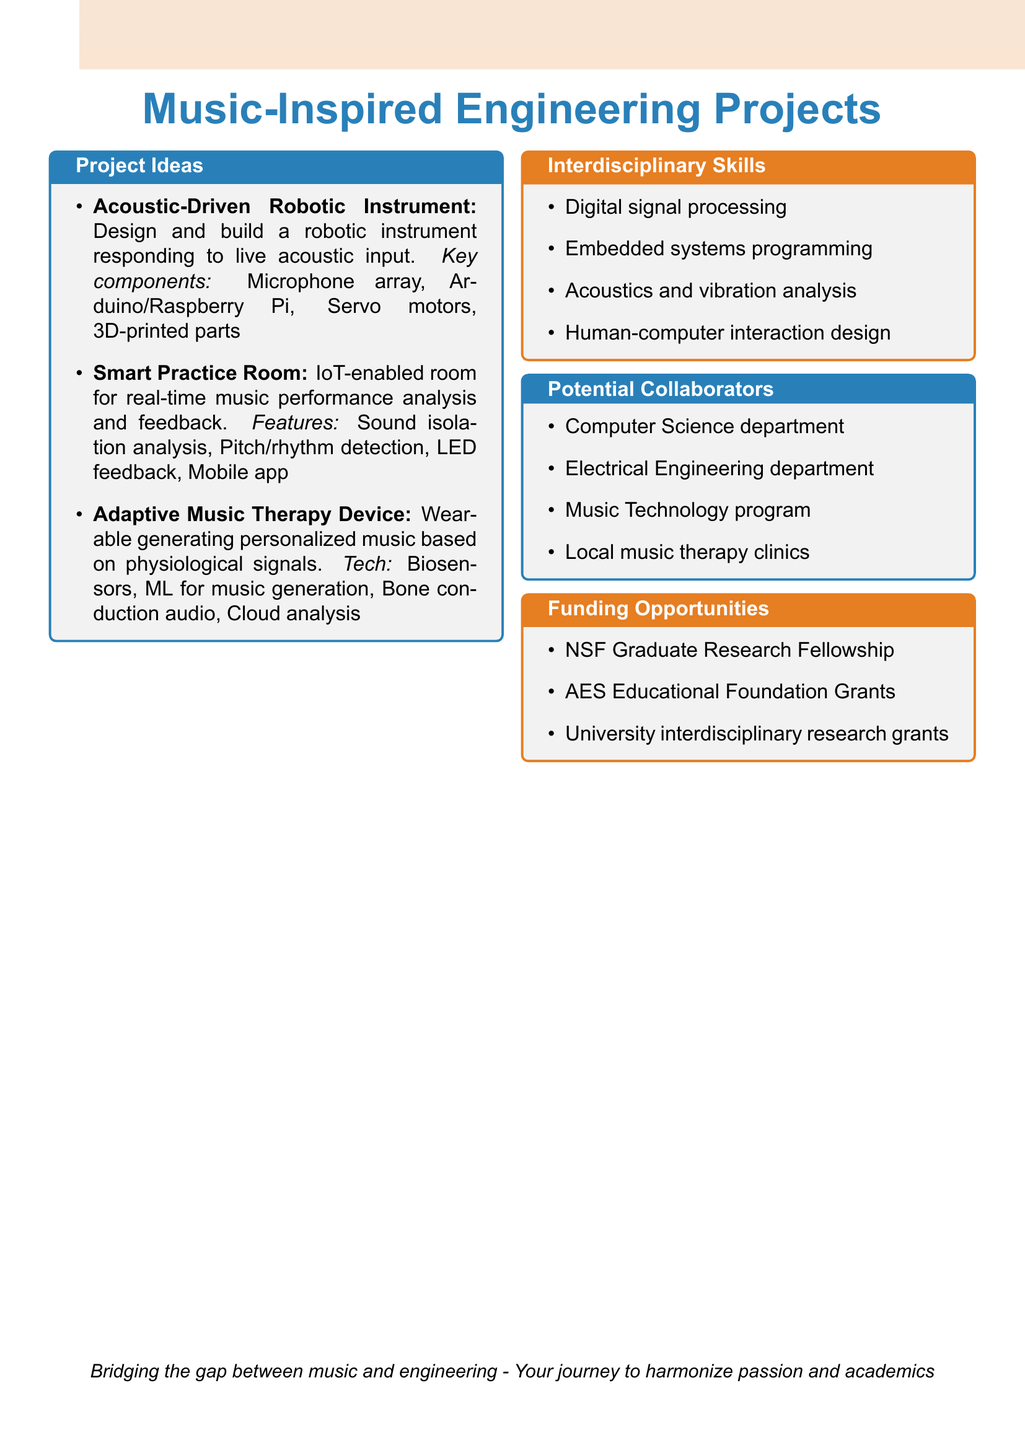What is the title of the first project? The title of the first project is listed in the project ideas section of the document.
Answer: Acoustic-Driven Robotic Instrument What are the key components of the Smart Practice Room? The key components of the Smart Practice Room are detailed in the project ideas section.
Answer: Sound isolation analysis, Pitch and rhythm detection algorithms, LED visual feedback system, Mobile app integration Which department collaborates on the Adaptive Music Therapy Device? This requires understanding which potential collaborators are listed for the projects.
Answer: Music Technology program What technology is used in the Adaptive Music Therapy Device? The document specifies the technologies used in the Adaptive Music Therapy Device under its description.
Answer: Biosensors (heart rate, skin conductance), Machine learning for music generation, Bone conduction audio output, Cloud-based data analysis How many interdisciplinary skills are mentioned in the document? The total number of interdisciplinary skills is compiled into a list in the document.
Answer: Four What funding opportunity is offered by the National Science Foundation? This information requires retrieving specific funding opportunities mentioned in the funding section.
Answer: NSF Graduate Research Fellowship Which project involves real-time feedback? By analyzing the project descriptions, this project focuses on providing real-time feedback during music performance.
Answer: Smart Practice Room What is one technology used for music generation in the Adaptive Music Therapy Device? This question focuses on the specific mention of technologies used in the Adaptive Music Therapy Device.
Answer: Machine learning for music generation 